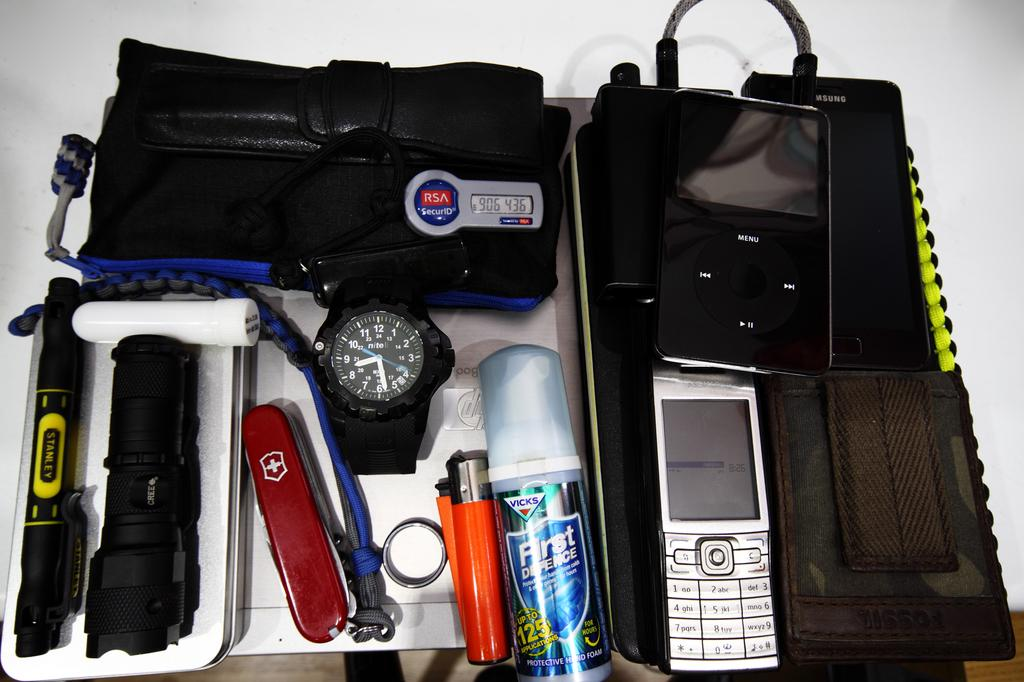What type of objects can be seen in the image? There is a watch, a torch, a bag, a music player, and a mobile in the image. How are these objects arranged in the image? All these objects are kept inside a bag. Where is the bag placed in the image? The bag is placed on the floor. Can you see a tiger walking near the bag in the image? No, there is no tiger present in the image. What type of degree is required to operate the music player in the image? There is no degree required to operate the music player in the image, as it is a simple electronic device. 